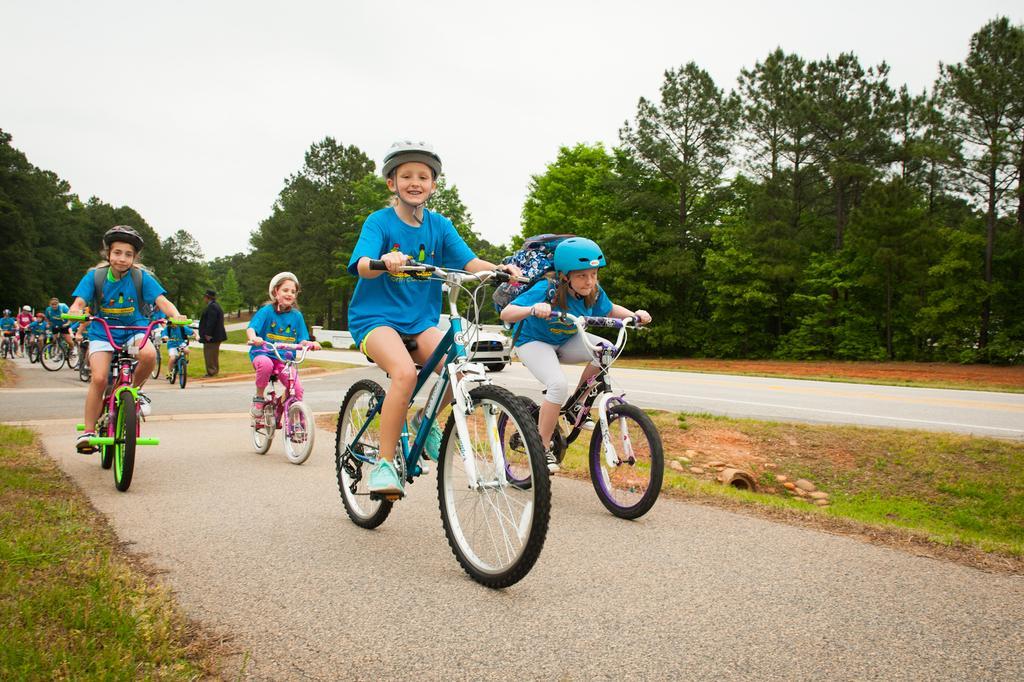How would you summarize this image in a sentence or two? In a given image we can see that, there are many children who are riding the bicycle on road. Around there are many trees. The sky is in white color. 